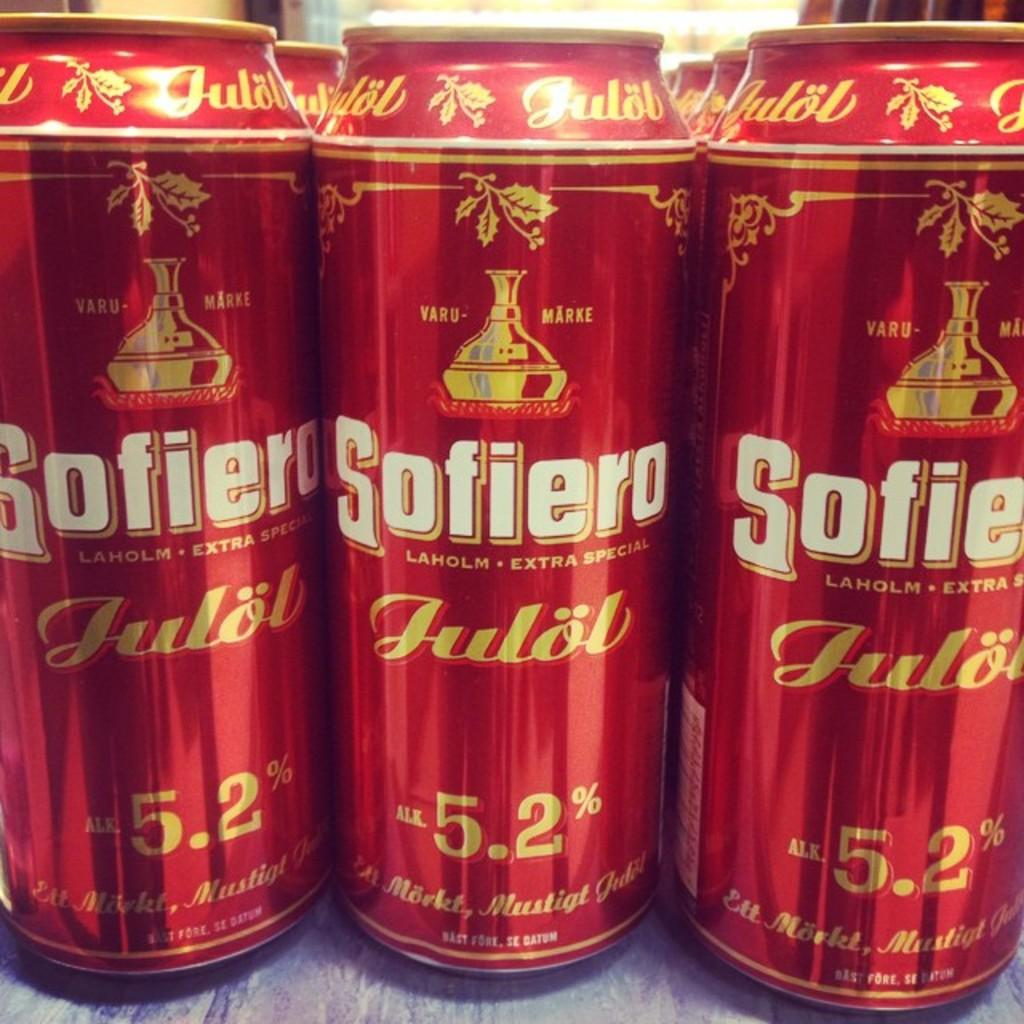<image>
Provide a brief description of the given image. some red cans with sofiero written on it 